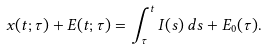Convert formula to latex. <formula><loc_0><loc_0><loc_500><loc_500>x ( t ; \tau ) + E ( t ; \tau ) = \int _ { \tau } ^ { t } I ( s ) \, d s + E _ { 0 } ( \tau ) .</formula> 